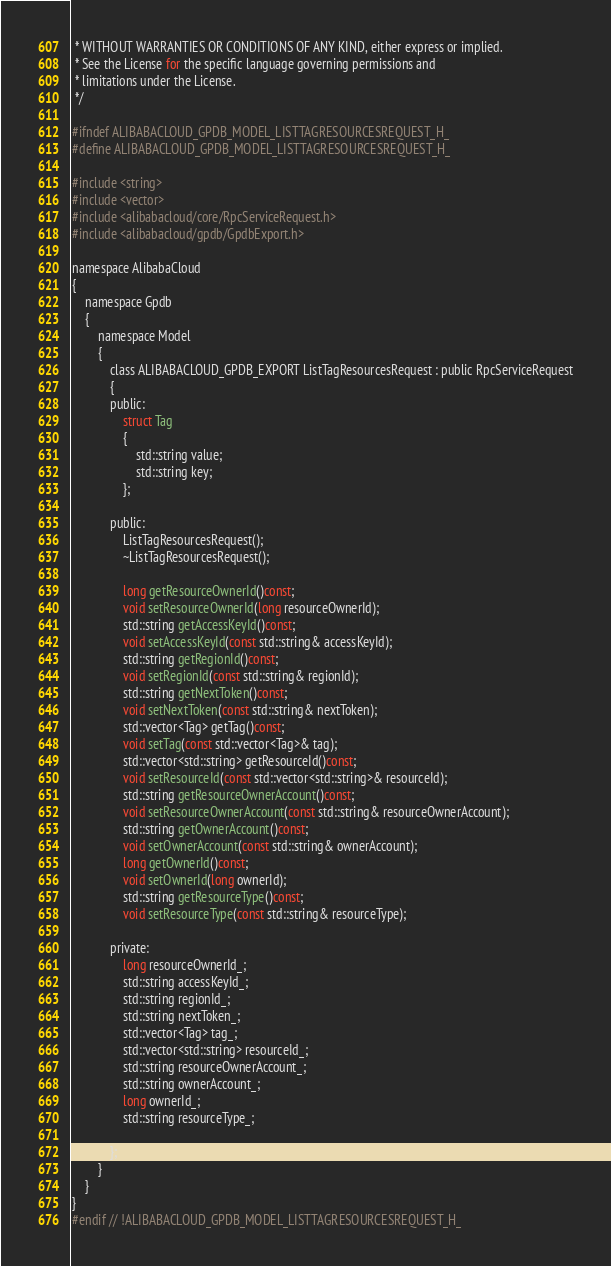Convert code to text. <code><loc_0><loc_0><loc_500><loc_500><_C_> * WITHOUT WARRANTIES OR CONDITIONS OF ANY KIND, either express or implied.
 * See the License for the specific language governing permissions and
 * limitations under the License.
 */

#ifndef ALIBABACLOUD_GPDB_MODEL_LISTTAGRESOURCESREQUEST_H_
#define ALIBABACLOUD_GPDB_MODEL_LISTTAGRESOURCESREQUEST_H_

#include <string>
#include <vector>
#include <alibabacloud/core/RpcServiceRequest.h>
#include <alibabacloud/gpdb/GpdbExport.h>

namespace AlibabaCloud
{
	namespace Gpdb
	{
		namespace Model
		{
			class ALIBABACLOUD_GPDB_EXPORT ListTagResourcesRequest : public RpcServiceRequest
			{
			public:
				struct Tag
				{
					std::string value;
					std::string key;
				};

			public:
				ListTagResourcesRequest();
				~ListTagResourcesRequest();

				long getResourceOwnerId()const;
				void setResourceOwnerId(long resourceOwnerId);
				std::string getAccessKeyId()const;
				void setAccessKeyId(const std::string& accessKeyId);
				std::string getRegionId()const;
				void setRegionId(const std::string& regionId);
				std::string getNextToken()const;
				void setNextToken(const std::string& nextToken);
				std::vector<Tag> getTag()const;
				void setTag(const std::vector<Tag>& tag);
				std::vector<std::string> getResourceId()const;
				void setResourceId(const std::vector<std::string>& resourceId);
				std::string getResourceOwnerAccount()const;
				void setResourceOwnerAccount(const std::string& resourceOwnerAccount);
				std::string getOwnerAccount()const;
				void setOwnerAccount(const std::string& ownerAccount);
				long getOwnerId()const;
				void setOwnerId(long ownerId);
				std::string getResourceType()const;
				void setResourceType(const std::string& resourceType);

            private:
				long resourceOwnerId_;
				std::string accessKeyId_;
				std::string regionId_;
				std::string nextToken_;
				std::vector<Tag> tag_;
				std::vector<std::string> resourceId_;
				std::string resourceOwnerAccount_;
				std::string ownerAccount_;
				long ownerId_;
				std::string resourceType_;

			};
		}
	}
}
#endif // !ALIBABACLOUD_GPDB_MODEL_LISTTAGRESOURCESREQUEST_H_</code> 